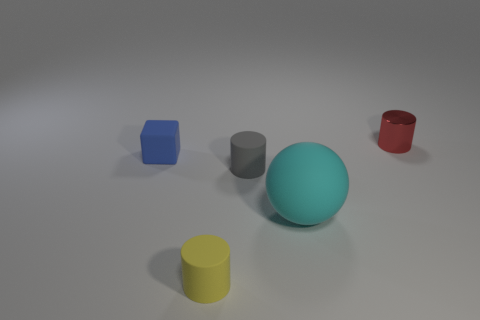Subtract all cyan cylinders. Subtract all cyan blocks. How many cylinders are left? 3 Add 5 large rubber spheres. How many objects exist? 10 Subtract all cylinders. How many objects are left? 2 Add 3 red things. How many red things are left? 4 Add 3 gray rubber things. How many gray rubber things exist? 4 Subtract 0 cyan cylinders. How many objects are left? 5 Subtract all cyan objects. Subtract all small blue rubber blocks. How many objects are left? 3 